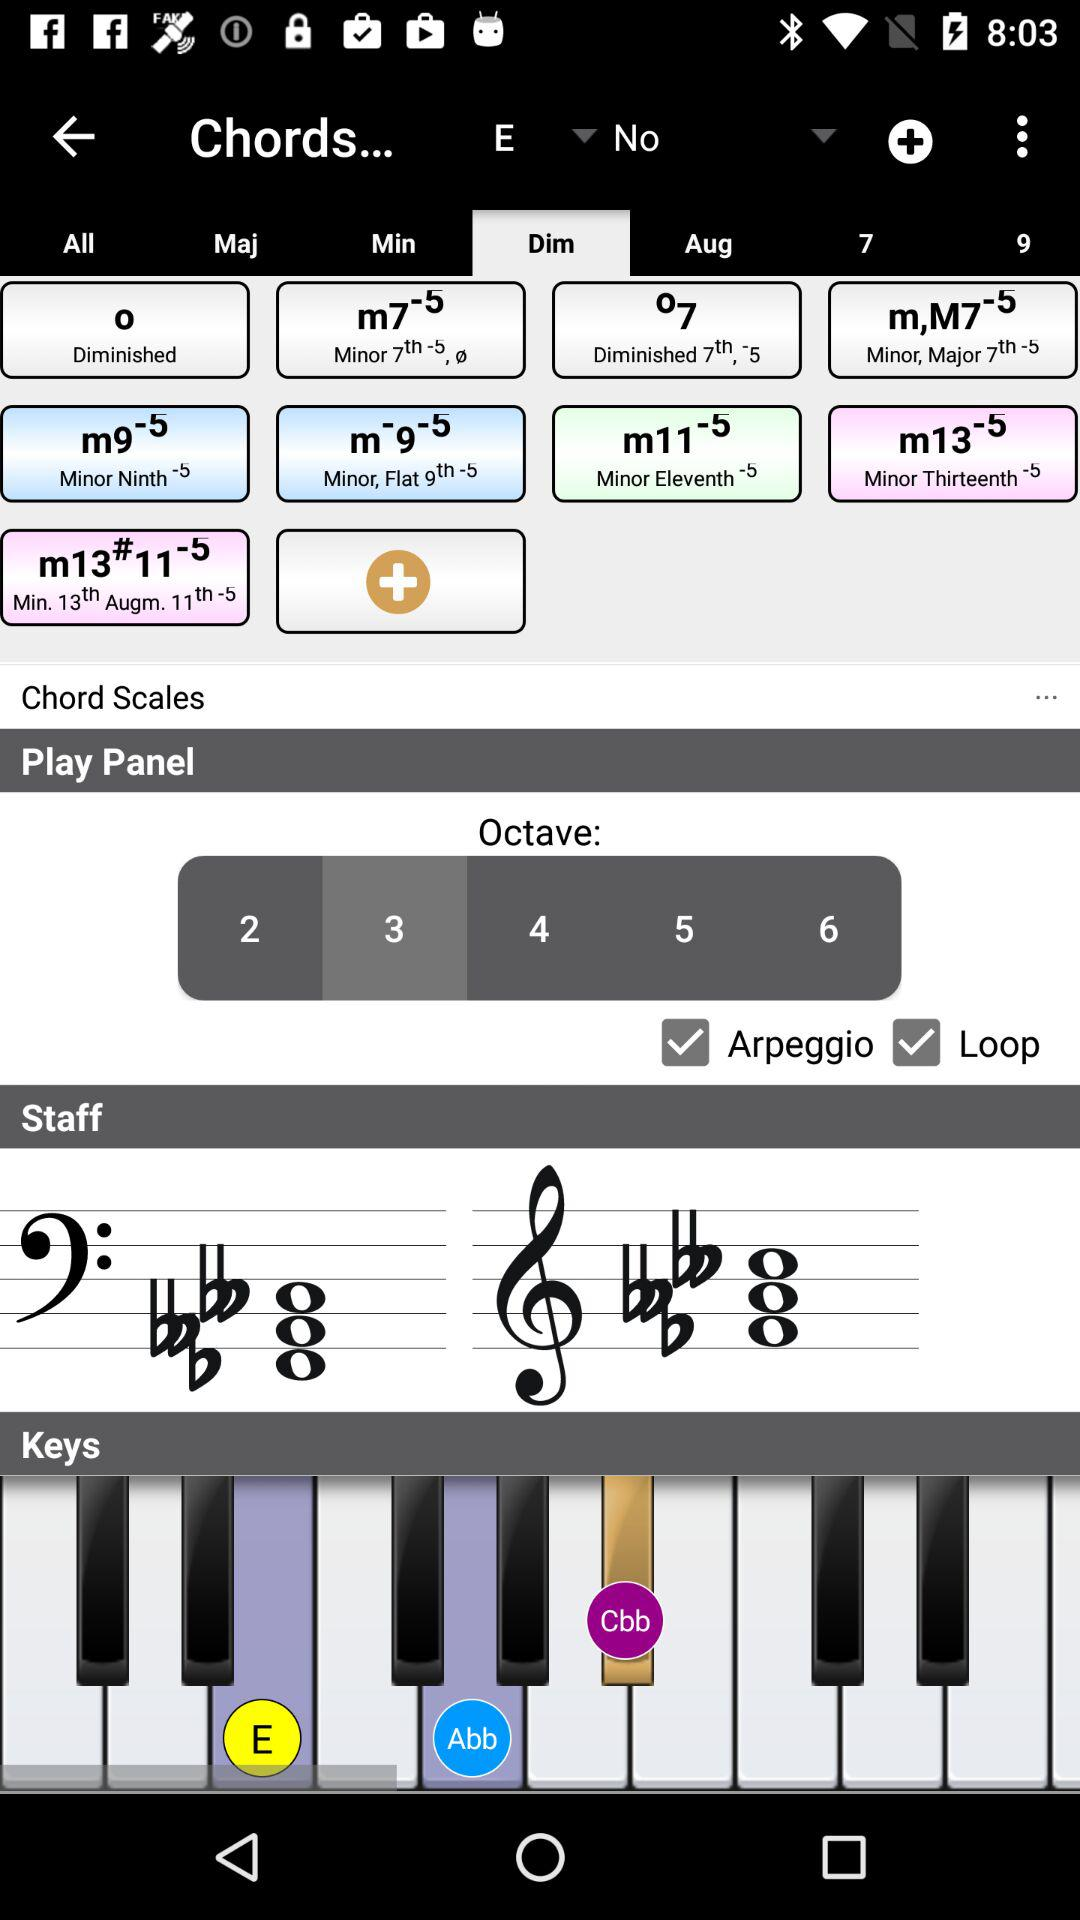Which octave is selected? The selected octave is 3. 